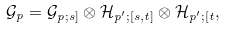Convert formula to latex. <formula><loc_0><loc_0><loc_500><loc_500>\mathcal { G } _ { p } = \mathcal { G } _ { p ; s ] } \otimes \mathcal { H } _ { p ^ { \prime } ; [ s , t ] } \otimes \mathcal { H } _ { p ^ { \prime } ; [ t } ,</formula> 